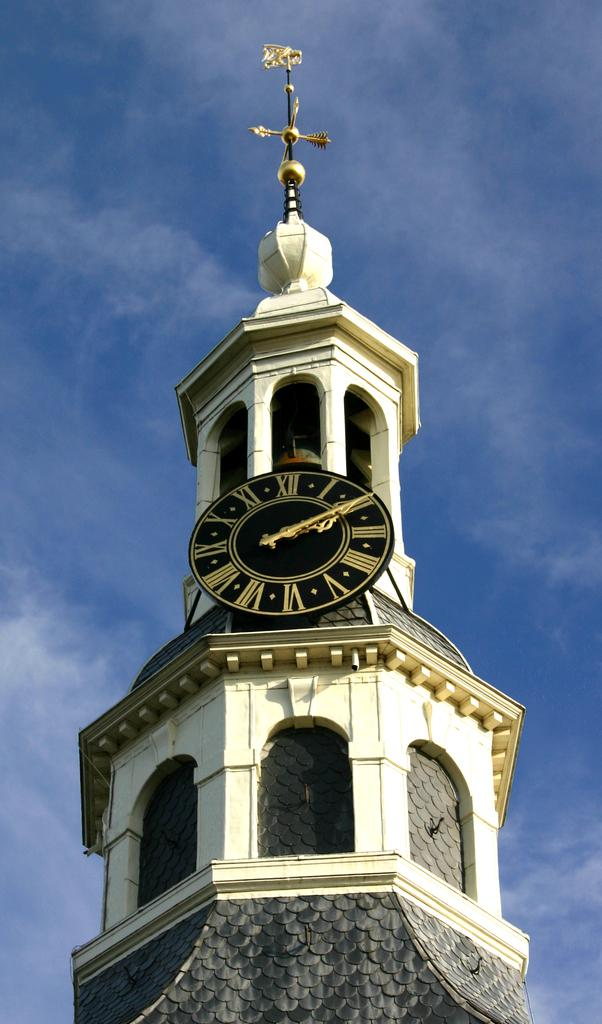What is the main structure in the image? There is a clock tower in the image. What colors can be seen in the sky in the background? The sky in the background is blue and white in color. What type of road is visible near the clock tower in the image? There is no road visible in the image; it only features the clock tower and the sky. What kind of meal is being prepared in the image? There is no meal preparation or any indication of food in the image. 